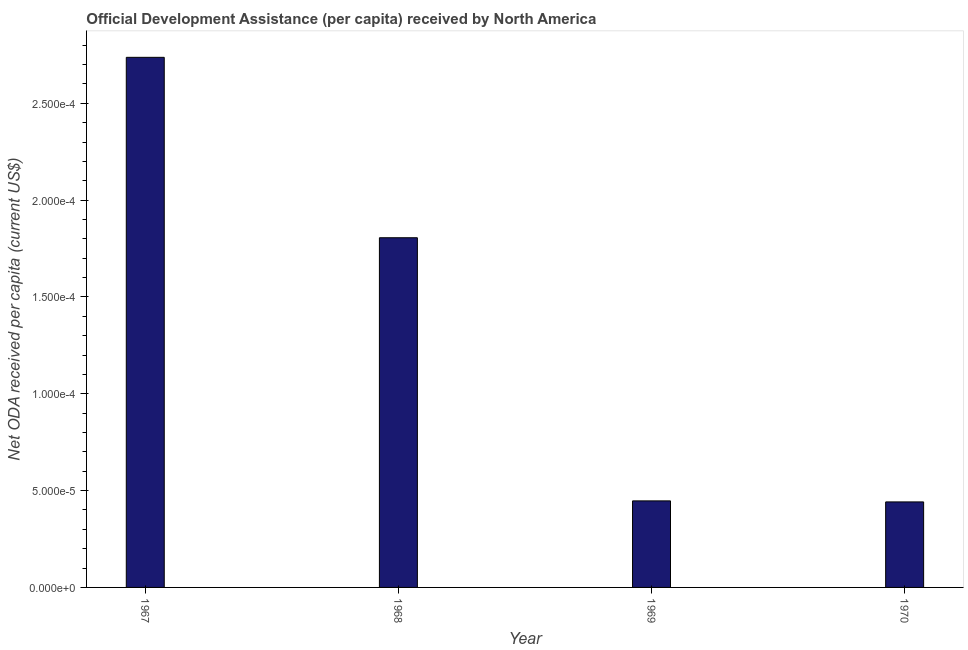What is the title of the graph?
Offer a very short reply. Official Development Assistance (per capita) received by North America. What is the label or title of the Y-axis?
Give a very brief answer. Net ODA received per capita (current US$). What is the net oda received per capita in 1967?
Offer a very short reply. 0. Across all years, what is the maximum net oda received per capita?
Provide a short and direct response. 0. Across all years, what is the minimum net oda received per capita?
Your answer should be very brief. 4.41635641762833e-5. In which year was the net oda received per capita maximum?
Keep it short and to the point. 1967. In which year was the net oda received per capita minimum?
Keep it short and to the point. 1970. What is the sum of the net oda received per capita?
Provide a succinct answer. 0. What is the median net oda received per capita?
Your answer should be very brief. 0. Do a majority of the years between 1967 and 1970 (inclusive) have net oda received per capita greater than 5e-05 US$?
Keep it short and to the point. No. What is the ratio of the net oda received per capita in 1969 to that in 1970?
Ensure brevity in your answer.  1.01. Is the net oda received per capita in 1969 less than that in 1970?
Keep it short and to the point. No. Is the difference between the net oda received per capita in 1967 and 1969 greater than the difference between any two years?
Your answer should be compact. No. How many bars are there?
Provide a short and direct response. 4. Are all the bars in the graph horizontal?
Your answer should be very brief. No. What is the difference between two consecutive major ticks on the Y-axis?
Ensure brevity in your answer.  5e-5. What is the Net ODA received per capita (current US$) of 1967?
Ensure brevity in your answer.  0. What is the Net ODA received per capita (current US$) in 1968?
Ensure brevity in your answer.  0. What is the Net ODA received per capita (current US$) of 1969?
Provide a short and direct response. 4.46909398057732e-5. What is the Net ODA received per capita (current US$) of 1970?
Keep it short and to the point. 4.41635641762833e-5. What is the difference between the Net ODA received per capita (current US$) in 1967 and 1968?
Provide a short and direct response. 9e-5. What is the difference between the Net ODA received per capita (current US$) in 1967 and 1969?
Your answer should be compact. 0. What is the difference between the Net ODA received per capita (current US$) in 1967 and 1970?
Provide a succinct answer. 0. What is the difference between the Net ODA received per capita (current US$) in 1968 and 1969?
Make the answer very short. 0. What is the difference between the Net ODA received per capita (current US$) in 1968 and 1970?
Ensure brevity in your answer.  0. What is the difference between the Net ODA received per capita (current US$) in 1969 and 1970?
Give a very brief answer. 0. What is the ratio of the Net ODA received per capita (current US$) in 1967 to that in 1968?
Offer a terse response. 1.52. What is the ratio of the Net ODA received per capita (current US$) in 1967 to that in 1969?
Provide a short and direct response. 6.12. What is the ratio of the Net ODA received per capita (current US$) in 1967 to that in 1970?
Your answer should be compact. 6.2. What is the ratio of the Net ODA received per capita (current US$) in 1968 to that in 1969?
Offer a terse response. 4.04. What is the ratio of the Net ODA received per capita (current US$) in 1968 to that in 1970?
Ensure brevity in your answer.  4.09. What is the ratio of the Net ODA received per capita (current US$) in 1969 to that in 1970?
Your answer should be very brief. 1.01. 